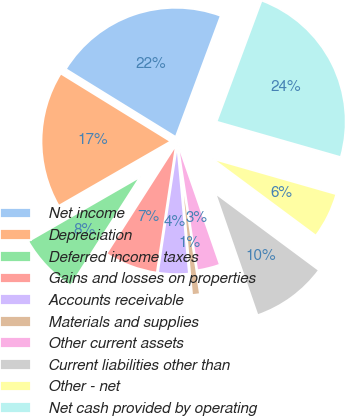Convert chart. <chart><loc_0><loc_0><loc_500><loc_500><pie_chart><fcel>Net income<fcel>Depreciation<fcel>Deferred income taxes<fcel>Gains and losses on properties<fcel>Accounts receivable<fcel>Materials and supplies<fcel>Other current assets<fcel>Current liabilities other than<fcel>Other - net<fcel>Net cash provided by operating<nl><fcel>21.87%<fcel>17.12%<fcel>7.63%<fcel>6.68%<fcel>3.83%<fcel>0.98%<fcel>2.88%<fcel>9.53%<fcel>5.73%<fcel>23.77%<nl></chart> 